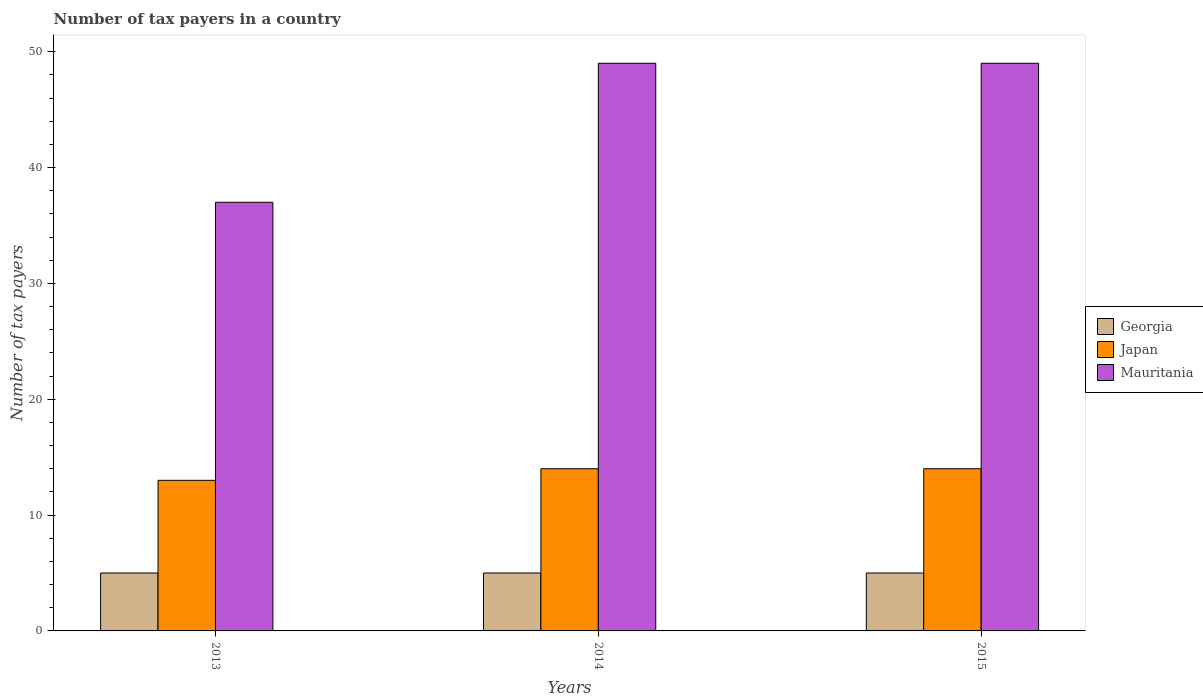How many different coloured bars are there?
Your answer should be compact. 3. Are the number of bars on each tick of the X-axis equal?
Your answer should be very brief. Yes. How many bars are there on the 2nd tick from the right?
Your response must be concise. 3. What is the label of the 2nd group of bars from the left?
Make the answer very short. 2014. In how many cases, is the number of bars for a given year not equal to the number of legend labels?
Offer a terse response. 0. What is the number of tax payers in in Mauritania in 2013?
Make the answer very short. 37. Across all years, what is the maximum number of tax payers in in Mauritania?
Provide a short and direct response. 49. Across all years, what is the minimum number of tax payers in in Georgia?
Offer a terse response. 5. In which year was the number of tax payers in in Japan maximum?
Your response must be concise. 2014. In which year was the number of tax payers in in Georgia minimum?
Give a very brief answer. 2013. What is the total number of tax payers in in Georgia in the graph?
Make the answer very short. 15. What is the difference between the number of tax payers in in Mauritania in 2015 and the number of tax payers in in Georgia in 2014?
Make the answer very short. 44. What is the average number of tax payers in in Georgia per year?
Your response must be concise. 5. In how many years, is the number of tax payers in in Mauritania greater than 18?
Ensure brevity in your answer.  3. What is the ratio of the number of tax payers in in Japan in 2014 to that in 2015?
Keep it short and to the point. 1. Is the difference between the number of tax payers in in Mauritania in 2013 and 2014 greater than the difference between the number of tax payers in in Japan in 2013 and 2014?
Give a very brief answer. No. What is the difference between the highest and the lowest number of tax payers in in Mauritania?
Your answer should be very brief. 12. What does the 3rd bar from the left in 2015 represents?
Offer a terse response. Mauritania. What does the 1st bar from the right in 2013 represents?
Make the answer very short. Mauritania. How many bars are there?
Your answer should be compact. 9. Does the graph contain any zero values?
Make the answer very short. No. Where does the legend appear in the graph?
Your response must be concise. Center right. How many legend labels are there?
Your answer should be compact. 3. How are the legend labels stacked?
Make the answer very short. Vertical. What is the title of the graph?
Provide a short and direct response. Number of tax payers in a country. What is the label or title of the X-axis?
Your answer should be compact. Years. What is the label or title of the Y-axis?
Offer a terse response. Number of tax payers. What is the Number of tax payers in Georgia in 2013?
Your response must be concise. 5. What is the Number of tax payers of Mauritania in 2013?
Your response must be concise. 37. What is the Number of tax payers of Georgia in 2015?
Provide a short and direct response. 5. What is the Number of tax payers of Japan in 2015?
Your answer should be very brief. 14. Across all years, what is the maximum Number of tax payers in Japan?
Your answer should be very brief. 14. Across all years, what is the minimum Number of tax payers in Japan?
Offer a very short reply. 13. Across all years, what is the minimum Number of tax payers in Mauritania?
Make the answer very short. 37. What is the total Number of tax payers in Mauritania in the graph?
Ensure brevity in your answer.  135. What is the difference between the Number of tax payers of Georgia in 2013 and that in 2014?
Make the answer very short. 0. What is the difference between the Number of tax payers in Japan in 2013 and that in 2014?
Keep it short and to the point. -1. What is the difference between the Number of tax payers of Mauritania in 2013 and that in 2014?
Offer a very short reply. -12. What is the difference between the Number of tax payers of Japan in 2013 and that in 2015?
Provide a short and direct response. -1. What is the difference between the Number of tax payers in Mauritania in 2013 and that in 2015?
Offer a very short reply. -12. What is the difference between the Number of tax payers of Georgia in 2014 and that in 2015?
Give a very brief answer. 0. What is the difference between the Number of tax payers in Japan in 2014 and that in 2015?
Make the answer very short. 0. What is the difference between the Number of tax payers of Georgia in 2013 and the Number of tax payers of Mauritania in 2014?
Your answer should be very brief. -44. What is the difference between the Number of tax payers in Japan in 2013 and the Number of tax payers in Mauritania in 2014?
Offer a terse response. -36. What is the difference between the Number of tax payers of Georgia in 2013 and the Number of tax payers of Mauritania in 2015?
Keep it short and to the point. -44. What is the difference between the Number of tax payers of Japan in 2013 and the Number of tax payers of Mauritania in 2015?
Keep it short and to the point. -36. What is the difference between the Number of tax payers of Georgia in 2014 and the Number of tax payers of Mauritania in 2015?
Your answer should be very brief. -44. What is the difference between the Number of tax payers of Japan in 2014 and the Number of tax payers of Mauritania in 2015?
Ensure brevity in your answer.  -35. What is the average Number of tax payers of Georgia per year?
Your response must be concise. 5. What is the average Number of tax payers in Japan per year?
Your answer should be compact. 13.67. What is the average Number of tax payers of Mauritania per year?
Offer a very short reply. 45. In the year 2013, what is the difference between the Number of tax payers of Georgia and Number of tax payers of Mauritania?
Offer a very short reply. -32. In the year 2013, what is the difference between the Number of tax payers in Japan and Number of tax payers in Mauritania?
Provide a succinct answer. -24. In the year 2014, what is the difference between the Number of tax payers of Georgia and Number of tax payers of Japan?
Make the answer very short. -9. In the year 2014, what is the difference between the Number of tax payers of Georgia and Number of tax payers of Mauritania?
Provide a succinct answer. -44. In the year 2014, what is the difference between the Number of tax payers of Japan and Number of tax payers of Mauritania?
Keep it short and to the point. -35. In the year 2015, what is the difference between the Number of tax payers in Georgia and Number of tax payers in Japan?
Offer a very short reply. -9. In the year 2015, what is the difference between the Number of tax payers in Georgia and Number of tax payers in Mauritania?
Offer a terse response. -44. In the year 2015, what is the difference between the Number of tax payers of Japan and Number of tax payers of Mauritania?
Offer a very short reply. -35. What is the ratio of the Number of tax payers in Japan in 2013 to that in 2014?
Offer a very short reply. 0.93. What is the ratio of the Number of tax payers of Mauritania in 2013 to that in 2014?
Make the answer very short. 0.76. What is the ratio of the Number of tax payers in Georgia in 2013 to that in 2015?
Offer a very short reply. 1. What is the ratio of the Number of tax payers of Mauritania in 2013 to that in 2015?
Your answer should be very brief. 0.76. What is the ratio of the Number of tax payers of Japan in 2014 to that in 2015?
Provide a short and direct response. 1. What is the ratio of the Number of tax payers of Mauritania in 2014 to that in 2015?
Give a very brief answer. 1. What is the difference between the highest and the second highest Number of tax payers of Georgia?
Your answer should be very brief. 0. What is the difference between the highest and the lowest Number of tax payers of Japan?
Offer a very short reply. 1. 